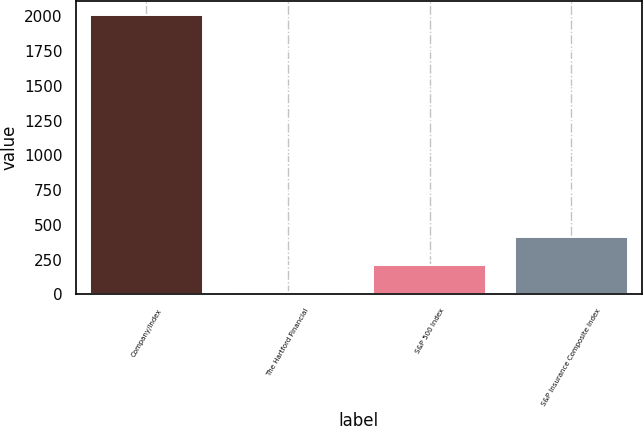Convert chart to OTSL. <chart><loc_0><loc_0><loc_500><loc_500><bar_chart><fcel>Company/Index<fcel>The Hartford Financial<fcel>S&P 500 Index<fcel>S&P Insurance Composite Index<nl><fcel>2010<fcel>14.89<fcel>214.4<fcel>413.91<nl></chart> 